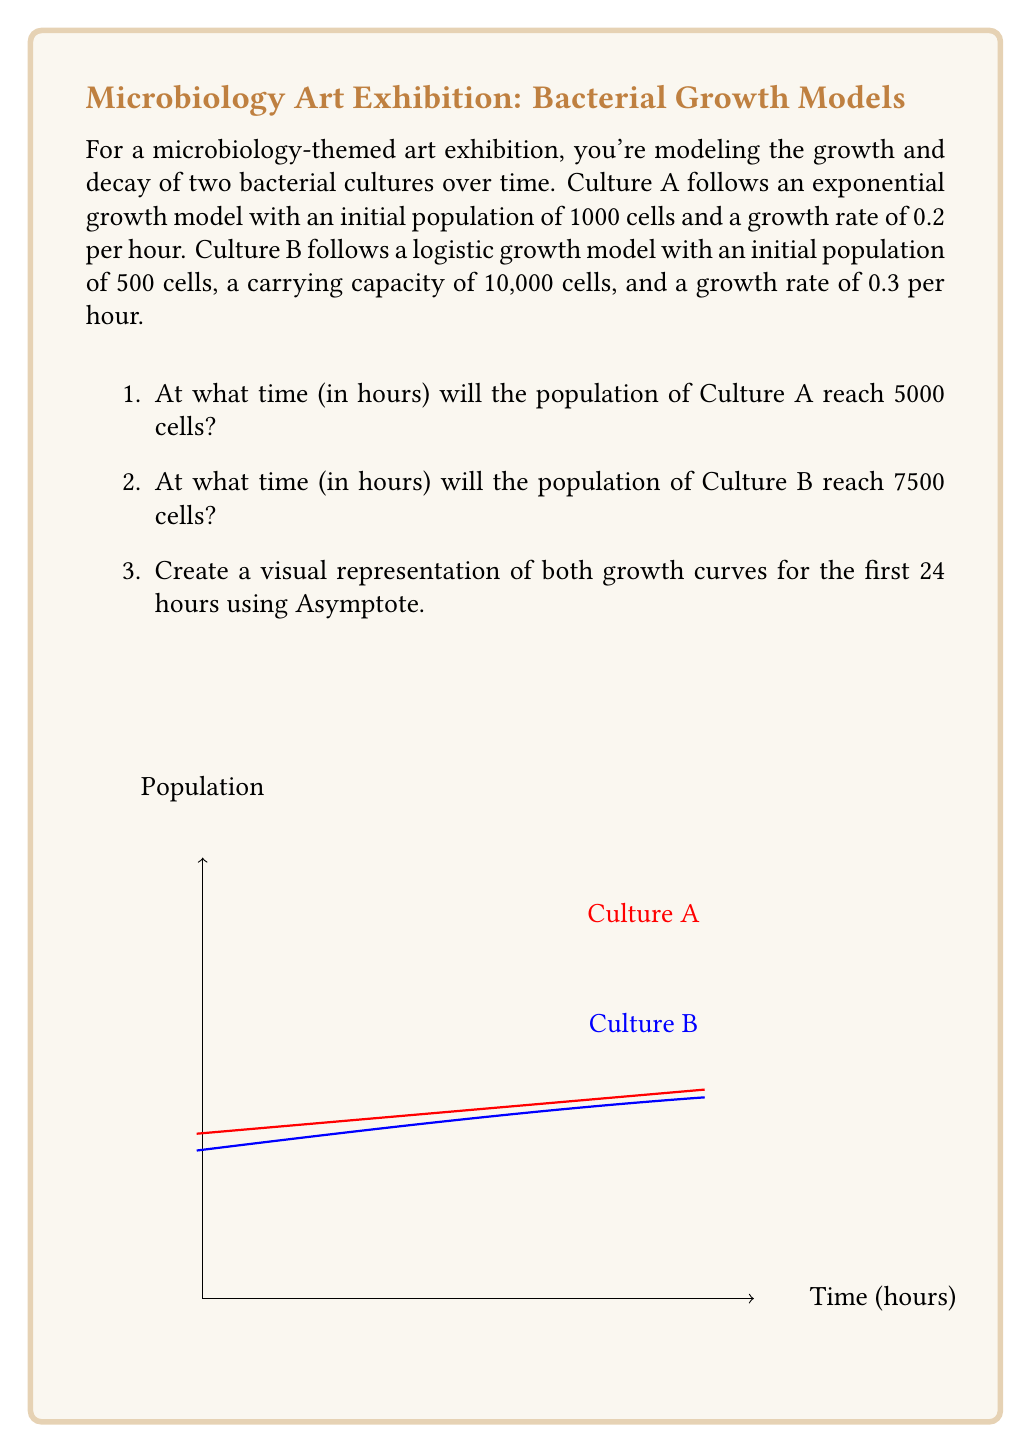Show me your answer to this math problem. Let's solve this problem step by step:

1) For Culture A (exponential growth):
   The model is given by $N(t) = N_0 e^{rt}$, where $N_0 = 1000$, $r = 0.2$, and we want $N(t) = 5000$.

   $5000 = 1000 e^{0.2t}$
   $5 = e^{0.2t}$
   $\ln(5) = 0.2t$
   $t = \frac{\ln(5)}{0.2} \approx 8.05$ hours

2) For Culture B (logistic growth):
   The model is given by $N(t) = \frac{K}{1 + (\frac{K}{N_0} - 1)e^{-rt}}$, where $K = 10000$, $N_0 = 500$, $r = 0.3$, and we want $N(t) = 7500$.

   $7500 = \frac{10000}{1 + (\frac{10000}{500} - 1)e^{-0.3t}}$
   $\frac{4}{3} = 1 + 19e^{-0.3t}$
   $\frac{1}{3} = 19e^{-0.3t}$
   $\ln(\frac{1}{57}) = -0.3t$
   $t = \frac{\ln(57)}{0.3} \approx 13.46$ hours

3) The Asymptote code provided in the question creates a visual representation of both growth curves for the first 24 hours.
Answer: 1) 8.05 hours
2) 13.46 hours
3) [Graph shown in question] 